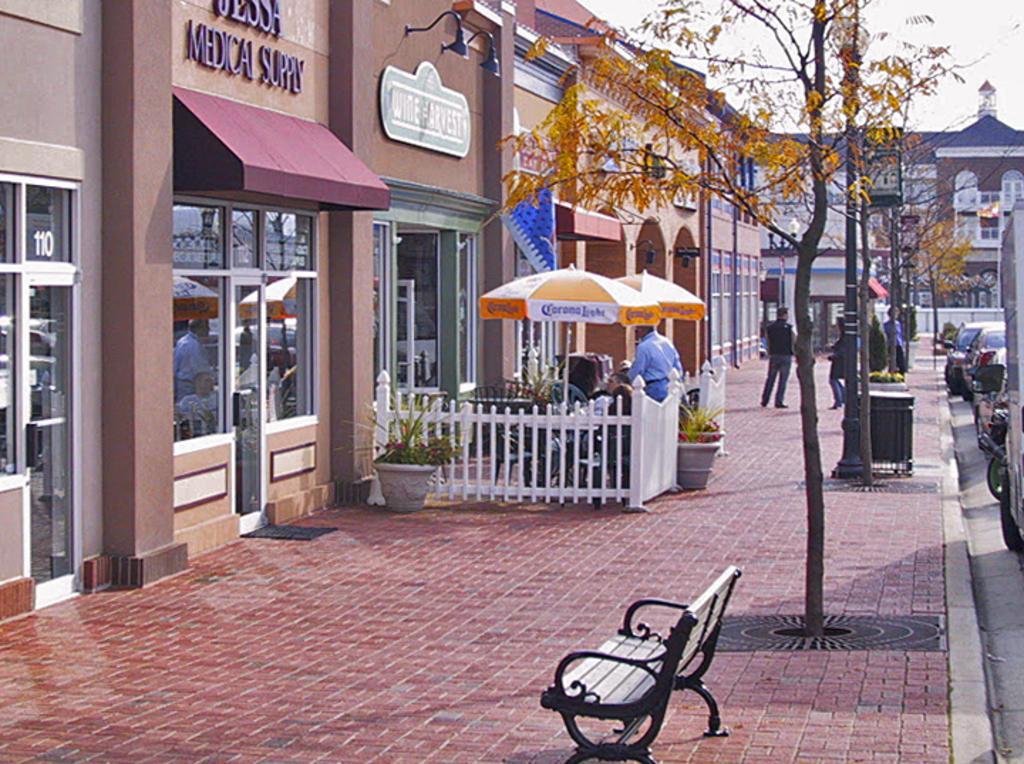Can you describe this image briefly? In this image, we can see buildings and we can see boards, umbrellas, railings, plants, people and there are vehicles on the road, some bins, trees and there is a bench and we can see light poles. At the top, there is sky. 